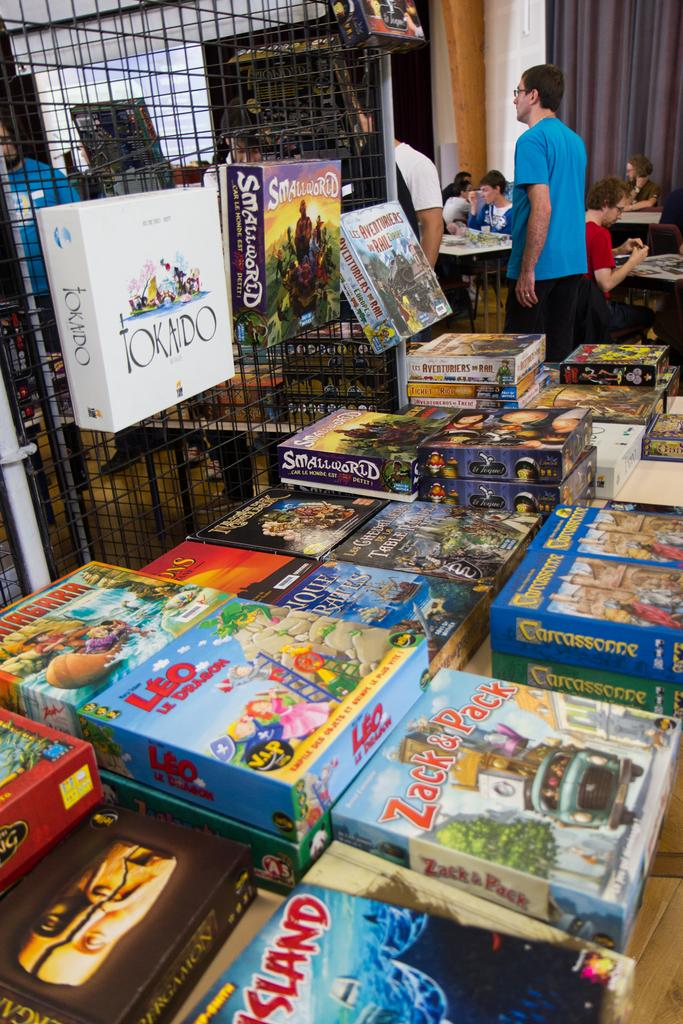<image>
Write a terse but informative summary of the picture. A Tokaido board game box is shown along with dozens of other games. 